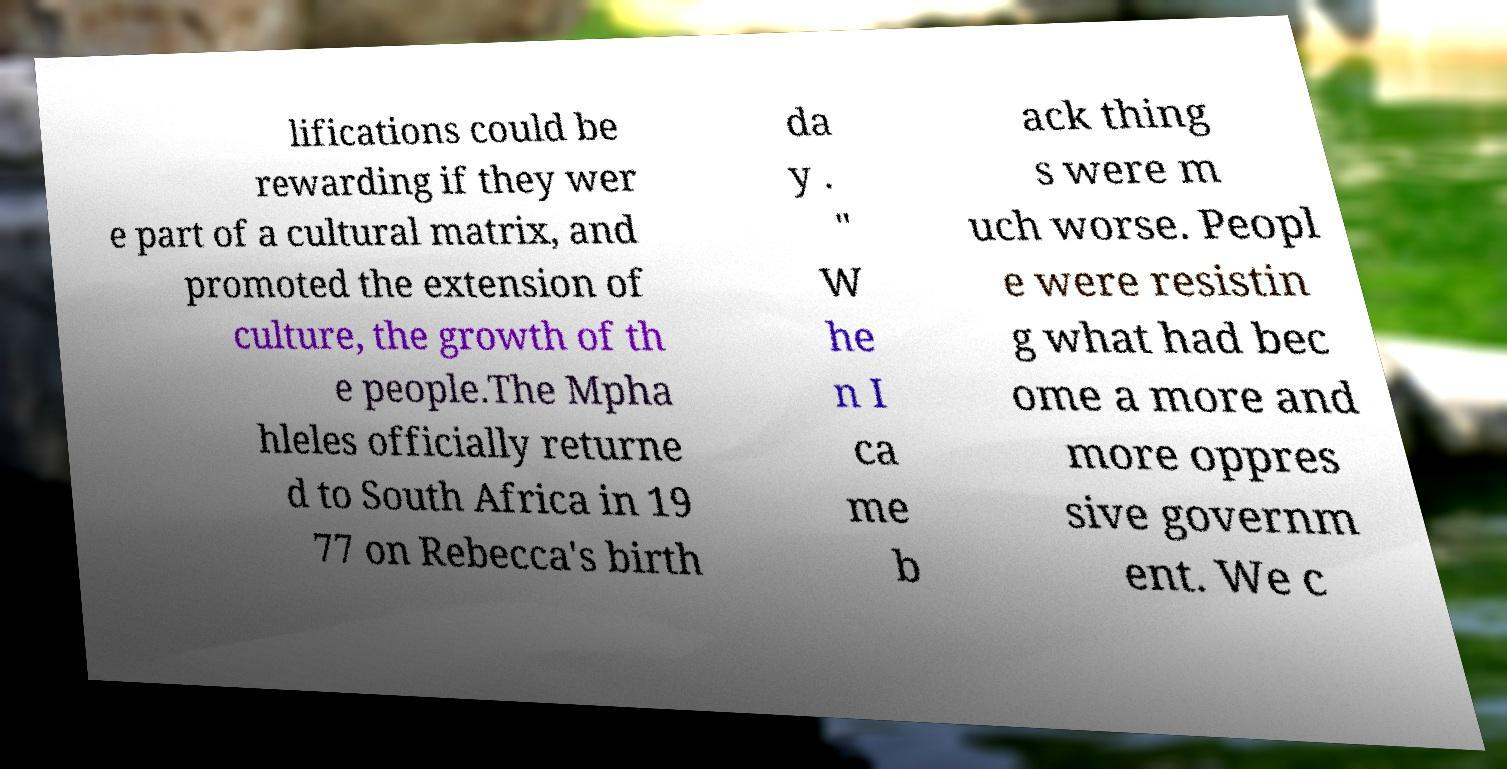I need the written content from this picture converted into text. Can you do that? lifications could be rewarding if they wer e part of a cultural matrix, and promoted the extension of culture, the growth of th e people.The Mpha hleles officially returne d to South Africa in 19 77 on Rebecca's birth da y . " W he n I ca me b ack thing s were m uch worse. Peopl e were resistin g what had bec ome a more and more oppres sive governm ent. We c 